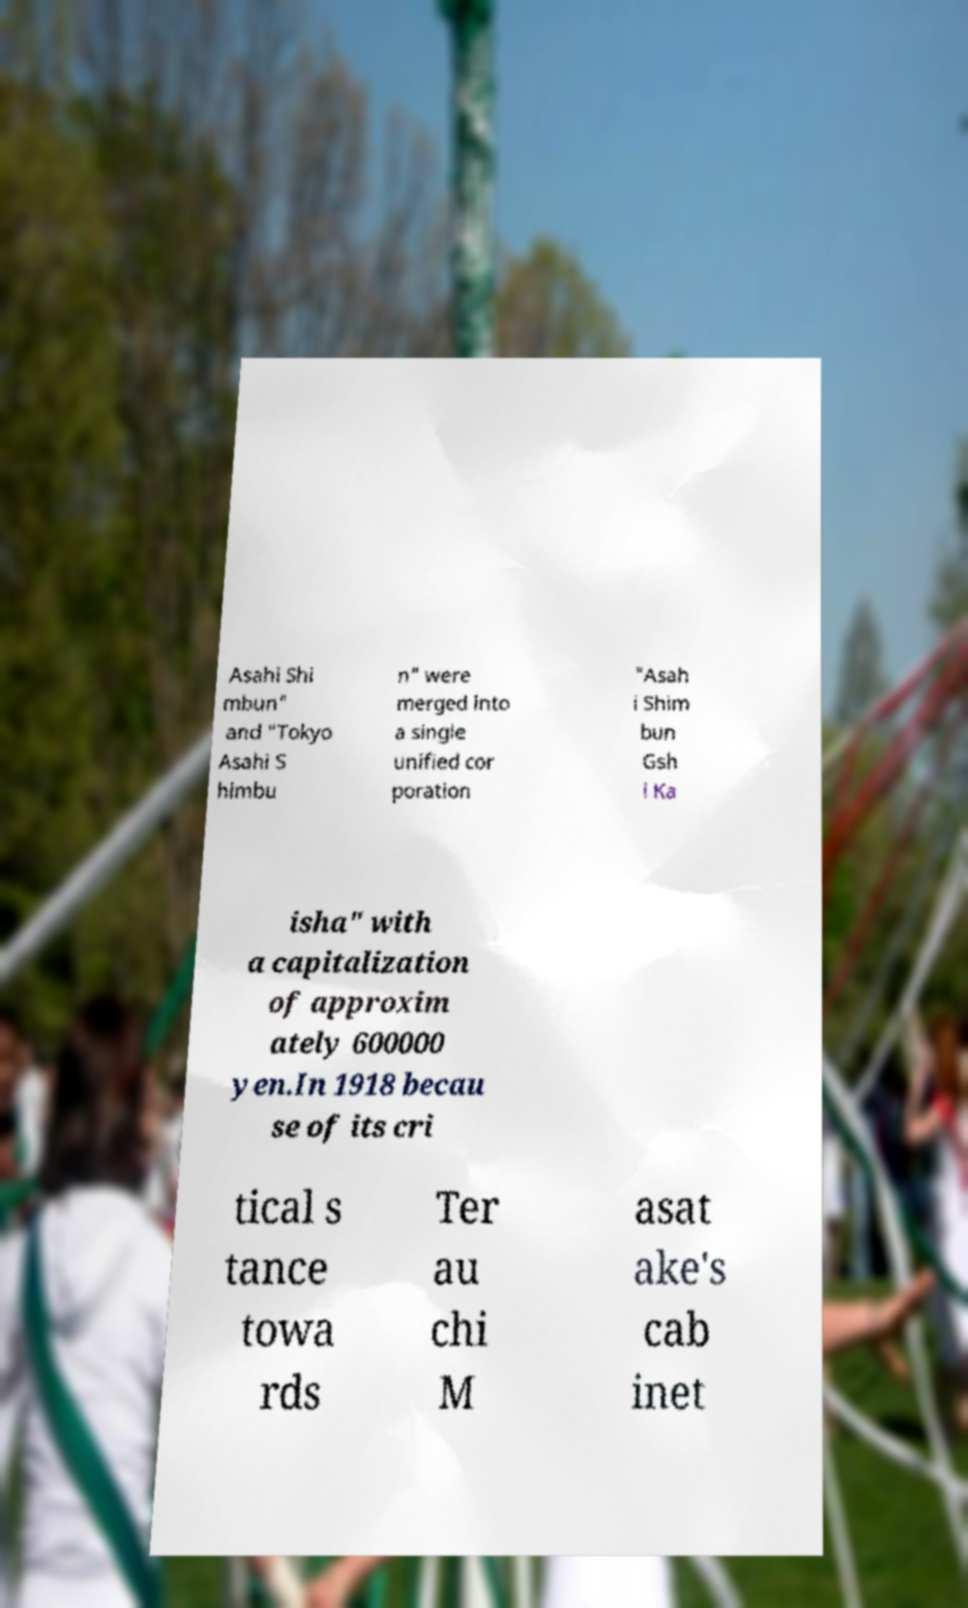For documentation purposes, I need the text within this image transcribed. Could you provide that? Asahi Shi mbun" and "Tokyo Asahi S himbu n" were merged into a single unified cor poration "Asah i Shim bun Gsh i Ka isha" with a capitalization of approxim ately 600000 yen.In 1918 becau se of its cri tical s tance towa rds Ter au chi M asat ake's cab inet 